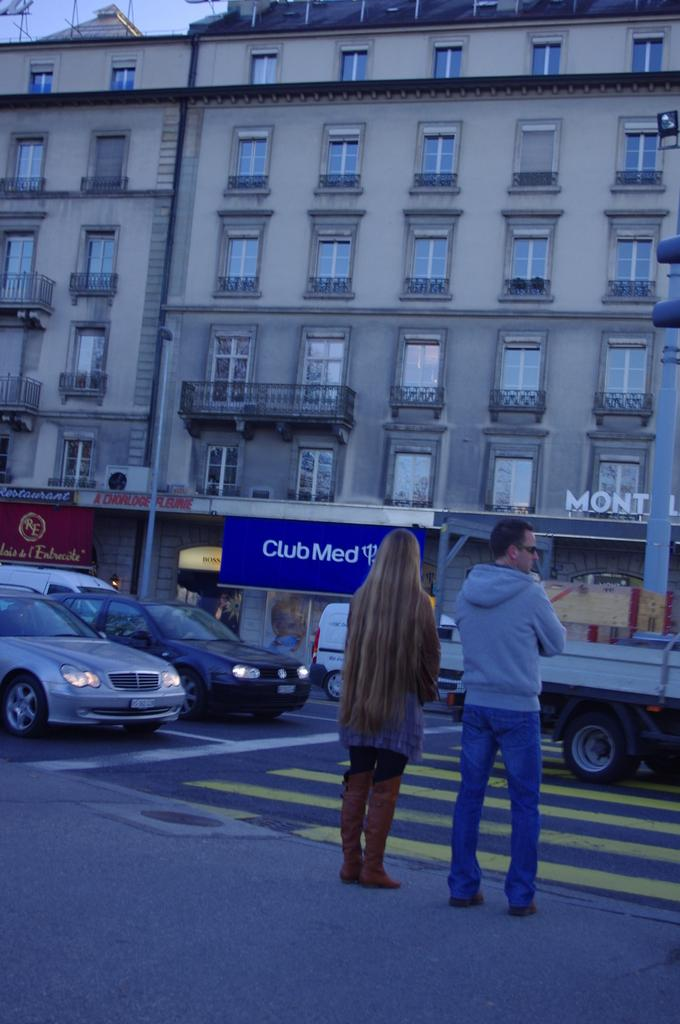How many people are in the image? There are two persons standing in the middle of the image. What can be seen in the background of the image? There are vehicles on the road in the background. What type of structures are visible at the top of the image? There are buildings visible at the top of the image. What type of ticket is being sold by the person on the left side of the image? There is no person on the left side of the image, and no ticket is being sold. Can you see any blades or stone objects in the image? There are no blades or stone objects present in the image. 